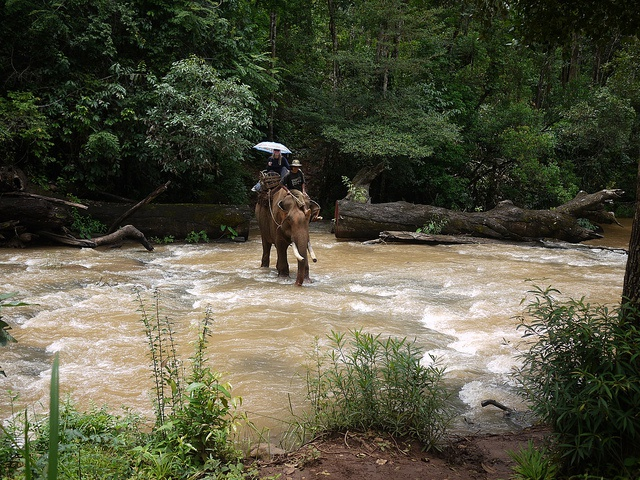Describe the objects in this image and their specific colors. I can see elephant in black, maroon, and gray tones, people in black, gray, and maroon tones, people in black, gray, and maroon tones, and umbrella in black, white, lightblue, and darkgray tones in this image. 